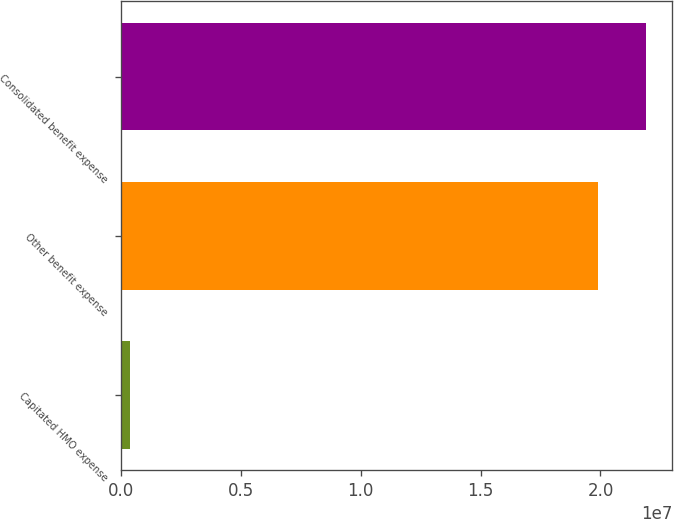<chart> <loc_0><loc_0><loc_500><loc_500><bar_chart><fcel>Capitated HMO expense<fcel>Other benefit expense<fcel>Consolidated benefit expense<nl><fcel>366075<fcel>1.99045e+07<fcel>2.18949e+07<nl></chart> 